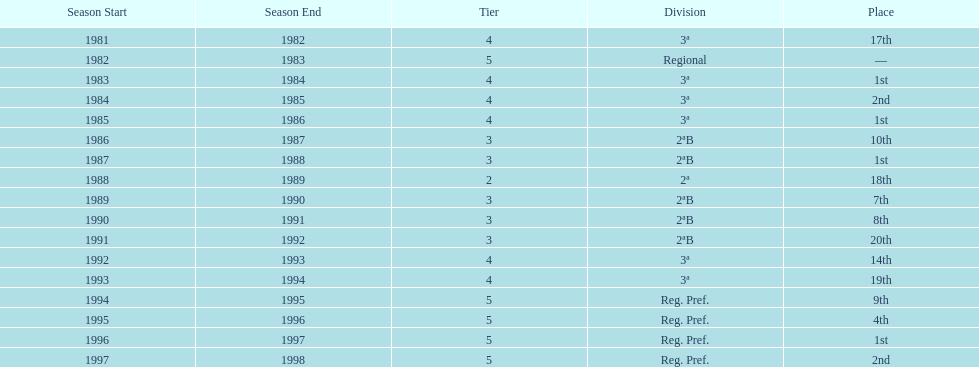What were the number of times second place was earned? 2. 